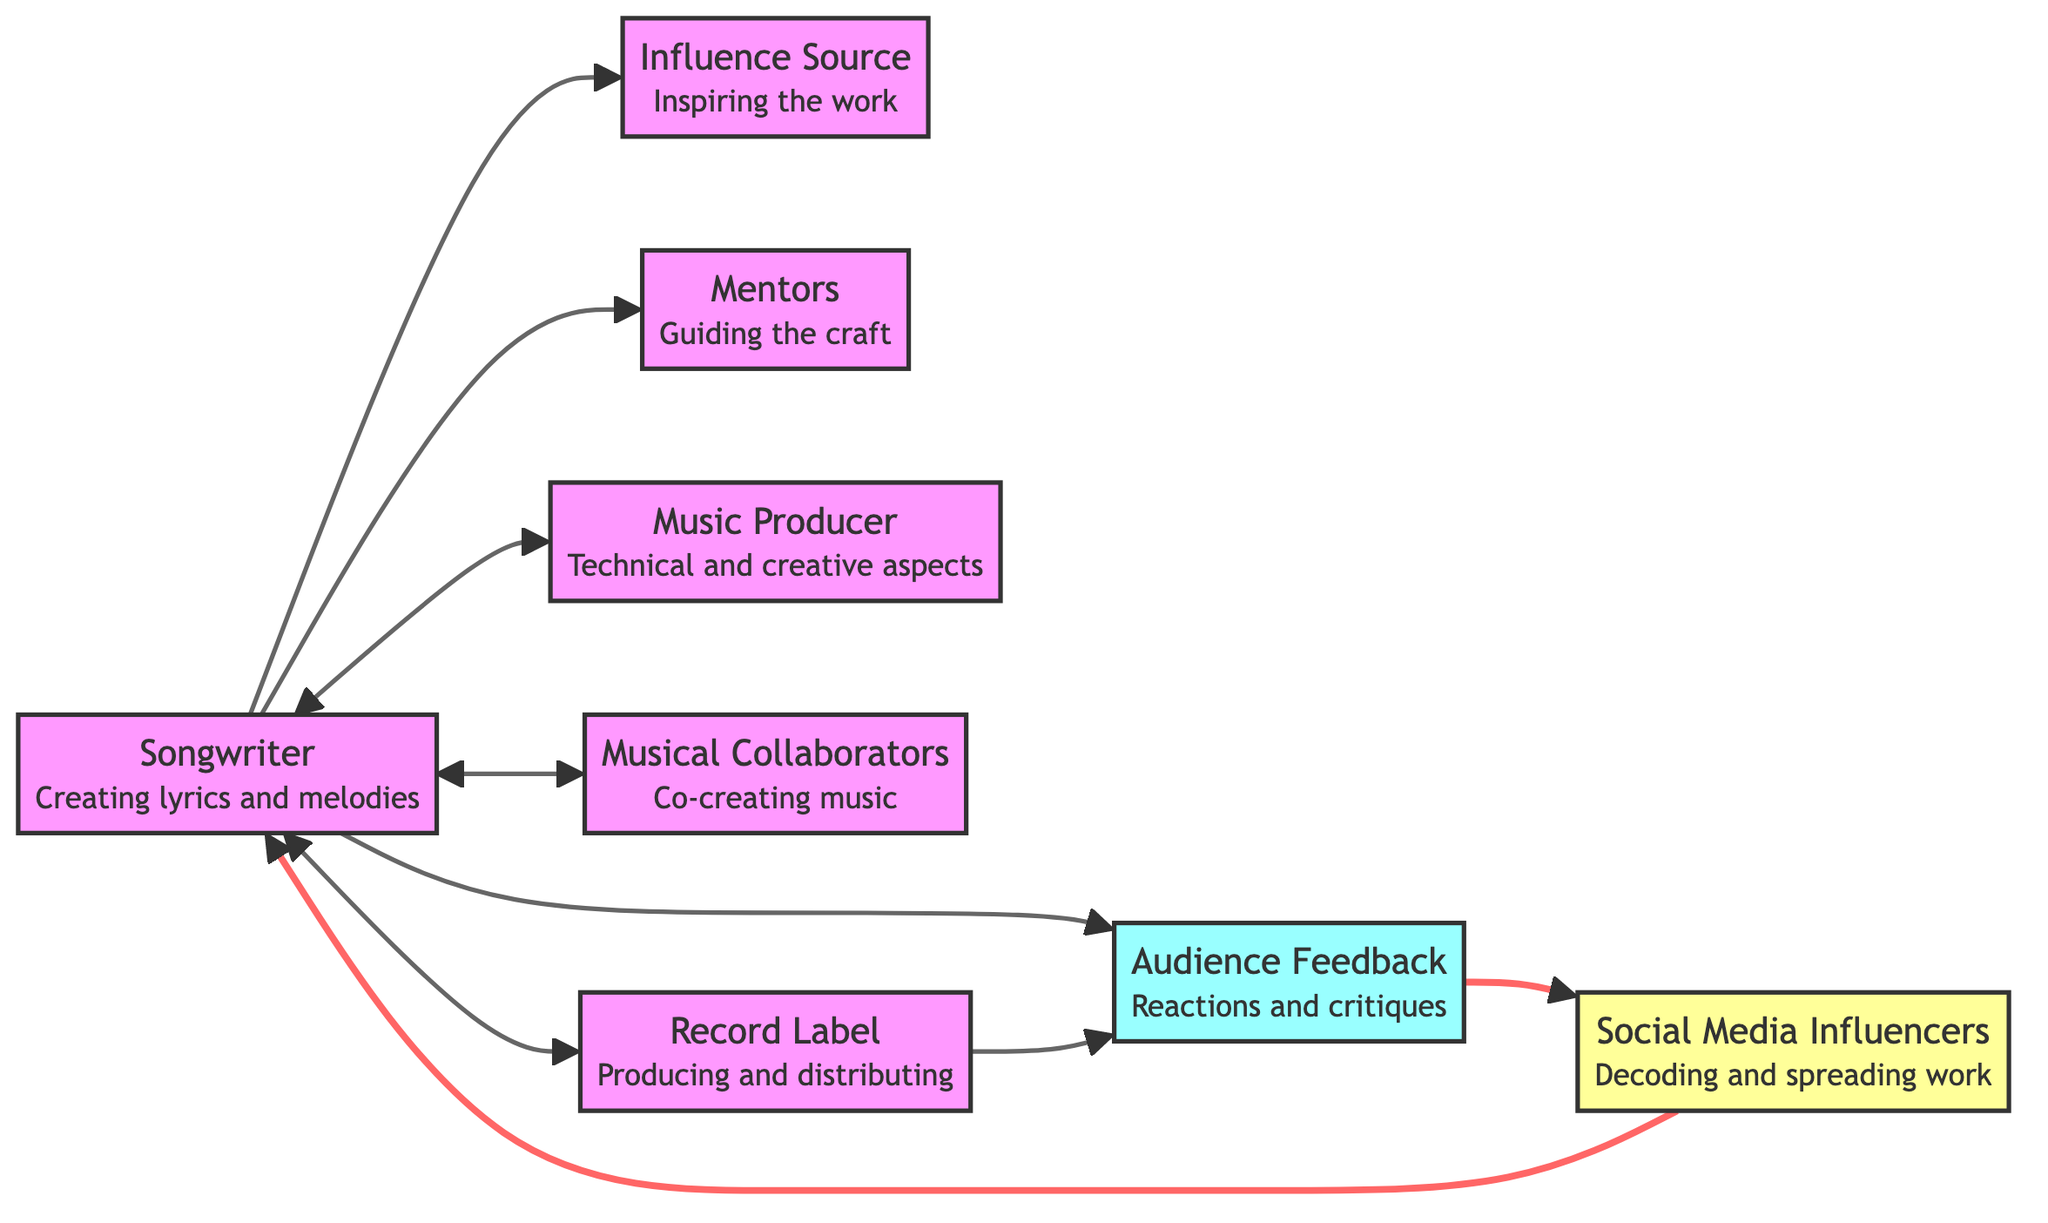What are the two ends of the edge that connects the Songwriter to the Music Producer? The edge represents a connection from the Songwriter to the Music Producer, showing their collaborative relationship. Thus, the two nodes are the "Songwriter" and "Music Producer."
Answer: Songwriter, Music Producer How many nodes are present in the diagram? The diagram contains a total of eight distinct nodes representing different aspects of a musician's career: Songwriter, Influence Source, Mentors, Music Producer, Musical Collaborators, Record Label, Audience Feedback, and Social Media Influencers.
Answer: 8 Which node shows the influence of Audience Feedback on the Songwriter? The diagram indicates a direct connection (edge) from the Audience Feedback node to the Songwriter node, illustrating how audience reactions and critiques influence the songwriter's work.
Answer: Audience Feedback What role do Social Media Influencers play in relation to the Songwriter? The diagram demonstrates that Social Media Influencers create a connection to the Songwriter, indicating that these influencers decode and amplify the songwriter's work, effectively boosting their visibility.
Answer: Decode and spread the work Which node is responsible for guiding and shaping the Songwriter's craft? In the diagram, the Mentors node is specifically listed as the entity responsible for providing guidance and shaping the Songwriter's artistic talent and craft.
Answer: Mentors What is the relationship between the Record Label and Audience Feedback? The edge between Record Label and Audience Feedback shows that the Record Label utilizes audience feedback to inform their decisions or strategies regarding music production and distribution.
Answer: Uses audience feedback How does Audience Feedback affect Social Media Influencers according to the diagram? The diagram depicts a connection from Audience Feedback to Social Media Influencers, signifying that feedback from the audience is leveraged by these influencers to promote and amplify the artist's music.
Answer: Leveraged by influencers What type of connections are shown between Songwriter and Musical Collaborators? The diagram depicts a bidirectional connection (represented by a double-headed arrow), demonstrating the collaborative nature of the relationship between the Songwriter and Musical Collaborators, indicating they co-create music together.
Answer: Collaboration connection What is the significance of the edge from Social Media Influencers back to the Songwriter? The diagram suggests a reciprocal relationship where Social Media Influencers not only promote the songwriter's work but also directly influence their career by decoding and helping spread their music, creating visibility for the artist.
Answer: Boosts the songwriter's work 